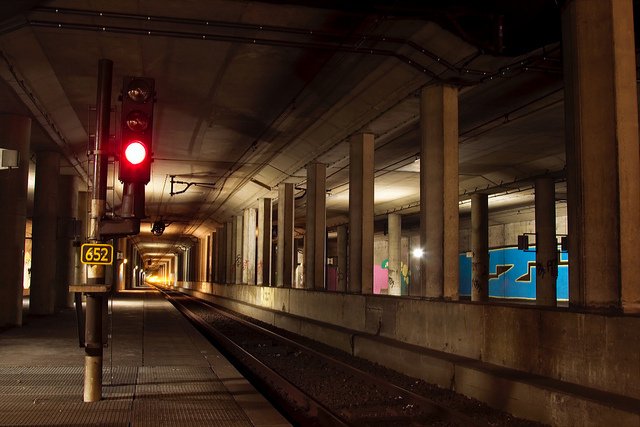Please transcribe the text in this image. 652 